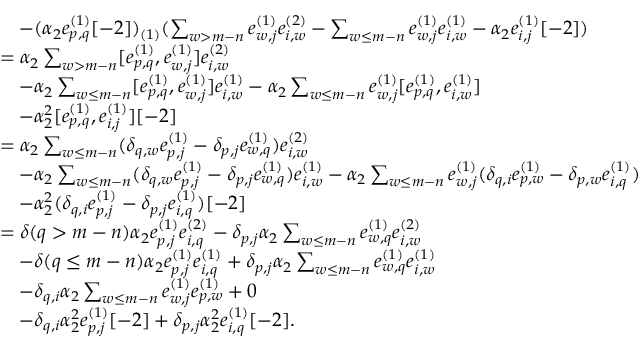Convert formula to latex. <formula><loc_0><loc_0><loc_500><loc_500>\begin{array} { r l } & { \quad - ( \alpha _ { 2 } e _ { p , q } ^ { ( 1 ) } [ - 2 ] ) _ { ( 1 ) } ( \sum _ { w > m - n } e _ { w , j } ^ { ( 1 ) } e _ { i , w } ^ { ( 2 ) } - \sum _ { w \leq m - n } e _ { w , j } ^ { ( 1 ) } e _ { i , w } ^ { ( 1 ) } - \alpha _ { 2 } e _ { i , j } ^ { ( 1 ) } [ - 2 ] ) } \\ & { = \alpha _ { 2 } \sum _ { w > m - n } [ e _ { p , q } ^ { ( 1 ) } , e _ { w , j } ^ { ( 1 ) } ] e _ { i , w } ^ { ( 2 ) } } \\ & { \quad - \alpha _ { 2 } \sum _ { w \leq m - n } [ e _ { p , q } ^ { ( 1 ) } , e _ { w , j } ^ { ( 1 ) } ] e _ { i , w } ^ { ( 1 ) } - \alpha _ { 2 } \sum _ { w \leq m - n } e _ { w , j } ^ { ( 1 ) } [ e _ { p , q } ^ { ( 1 ) } , e _ { i , w } ^ { ( 1 ) } ] } \\ & { \quad - \alpha _ { 2 } ^ { 2 } [ e _ { p , q } ^ { ( 1 ) } , e _ { i , j } ^ { ( 1 ) } ] [ - 2 ] } \\ & { = \alpha _ { 2 } \sum _ { w \leq m - n } ( \delta _ { q , w } e _ { p , j } ^ { ( 1 ) } - \delta _ { p , j } e _ { w , q } ^ { ( 1 ) } ) e _ { i , w } ^ { ( 2 ) } } \\ & { \quad - \alpha _ { 2 } \sum _ { w \leq m - n } ( \delta _ { q , w } e _ { p , j } ^ { ( 1 ) } - \delta _ { p , j } e _ { w , q } ^ { ( 1 ) } ) e _ { i , w } ^ { ( 1 ) } - \alpha _ { 2 } \sum _ { w \leq m - n } e _ { w , j } ^ { ( 1 ) } ( \delta _ { q , i } e _ { p , w } ^ { ( 1 ) } - \delta _ { p , w } e _ { i , q } ^ { ( 1 ) } ) } \\ & { \quad - \alpha _ { 2 } ^ { 2 } ( \delta _ { q , i } e _ { p , j } ^ { ( 1 ) } - \delta _ { p , j } e _ { i , q } ^ { ( 1 ) } ) [ - 2 ] } \\ & { = \delta ( q > m - n ) \alpha _ { 2 } e _ { p , j } ^ { ( 1 ) } e _ { i , q } ^ { ( 2 ) } - \delta _ { p , j } \alpha _ { 2 } \sum _ { w \leq m - n } e _ { w , q } ^ { ( 1 ) } e _ { i , w } ^ { ( 2 ) } } \\ & { \quad - \delta ( q \leq m - n ) \alpha _ { 2 } e _ { p , j } ^ { ( 1 ) } e _ { i , q } ^ { ( 1 ) } + \delta _ { p , j } \alpha _ { 2 } \sum _ { w \leq m - n } e _ { w , q } ^ { ( 1 ) } e _ { i , w } ^ { ( 1 ) } } \\ & { \quad - \delta _ { q , i } \alpha _ { 2 } \sum _ { w \leq m - n } e _ { w , j } ^ { ( 1 ) } e _ { p , w } ^ { ( 1 ) } + 0 } \\ & { \quad - \delta _ { q , i } \alpha _ { 2 } ^ { 2 } e _ { p , j } ^ { ( 1 ) } [ - 2 ] + \delta _ { p , j } \alpha _ { 2 } ^ { 2 } e _ { i , q } ^ { ( 1 ) } [ - 2 ] . } \end{array}</formula> 